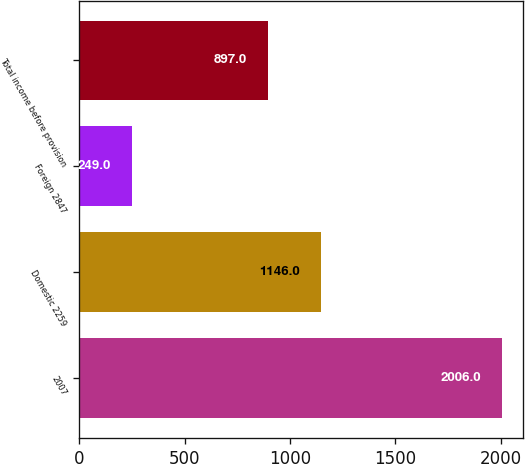Convert chart. <chart><loc_0><loc_0><loc_500><loc_500><bar_chart><fcel>2007<fcel>Domestic 2259<fcel>Foreign 2847<fcel>Total income before provision<nl><fcel>2006<fcel>1146<fcel>249<fcel>897<nl></chart> 